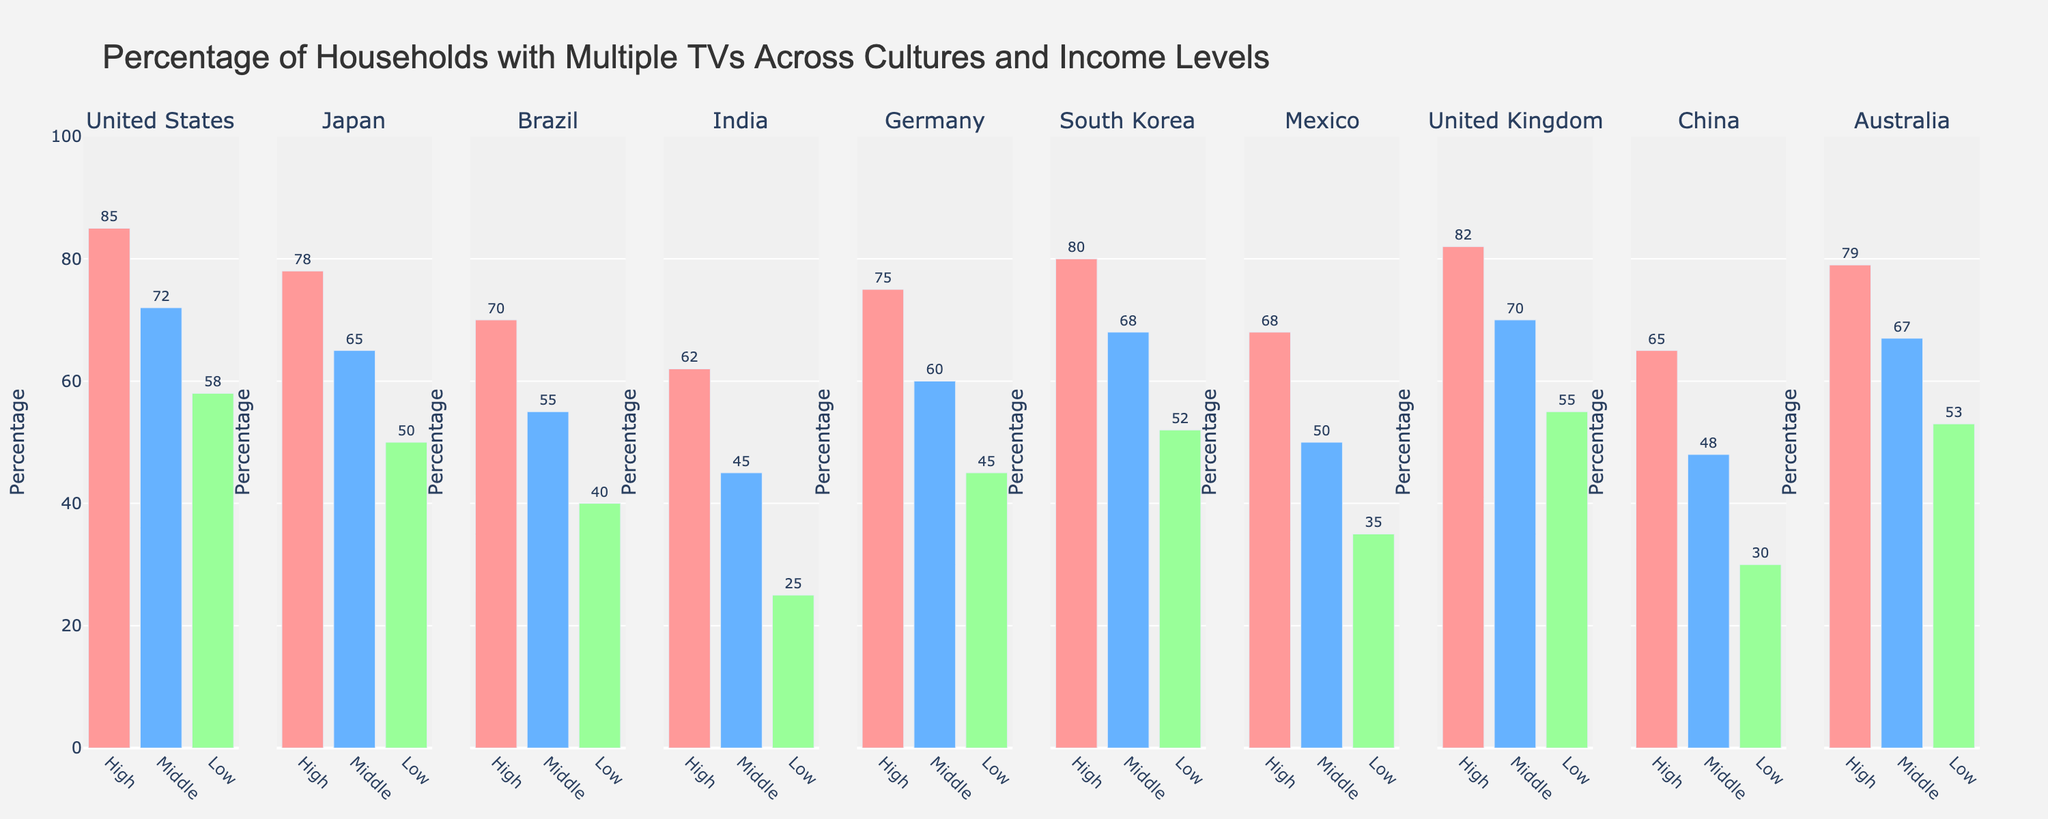what culture has the lowest percentage of households with multiple TVs in the low-income category? Look at the bar heights in the "Low" income category for each culture. The shortest bar indicates the lowest percentage. Here, India has the shortest bar at 25%.
Answer: India which culture has the highest percentage of households with multiple TVs in the high-income category? Check the bar heights in the "High" income category for each culture. The tallest bar represents the highest percentage. In this case, the United States has the tallest bar at 85%.
Answer: United States what is the average percentage of households with multiple TVs in the middle-income category across all cultures? Examine the "Middle" income bars for each culture and sum their values: (72 + 65 + 55 + 45 + 60 + 68 + 50 + 70 + 48 + 67). Then, divide by the number of cultures, which is 11. The average is 600/11 = 54.55%.
Answer: 54.55% how does the percentage of households with multiple TVs in the low-income category compare between the United States and Brazil? Look at the low-income bars for the United States and Brazil. The bar for the United States is at 58%, while the bar for Brazil is at 40%.
Answer: The United States has a higher percentage which income category has the most consistent percentages of households with multiple TVs across different cultures? Observe the range of bar heights within each income category. The "High" income category bars appear more consistent in height than the "Middle" and "Low" income categories.
Answer: High what is the percentage point difference between the highest and lowest percentages of households with multiple TVs within the "High" income group? Identify the highest and lowest percentages in the "High" income category. The highest is 85% (United States) and the lowest is 62% (India). The difference is 85% - 62% = 23%.
Answer: 23% which income level has the tallest bar for Japan? Look at the bars for Japan and identify the tallest one among the "High," "Middle," and "Low" income levels. The "High" income level bar is the tallest at 78%.
Answer: High in Germany, how much higher is the percentage of households with multiple TVs in the high-income category compared to the low-income category? Compare the percentages in the "High" and "Low" income categories for Germany. The "High" income category is at 75%, and the "Low" income category is at 45%. The difference is 75% - 45% = 30%.
Answer: 30% what is the median percentage of households with multiple TVs in the high-income category across all cultures? List the percentages in the "High" income category for each culture: 85, 78, 70, 62, 75, 80, 68, 82, 65, 79. Arrange them in ascending order: (62, 65, 68, 70, 75, 78, 79, 80, 82, 85). The median is the average of the 5th and 6th values: (75+78)/2 = 76.5%.
Answer: 76.5% which culture has the same percentage of households with multiple TVs in two different income categories? Look for any culture with two bars of the same height for two different income levels. None of the cultures share the same percentage value across two income levels.
Answer: None 